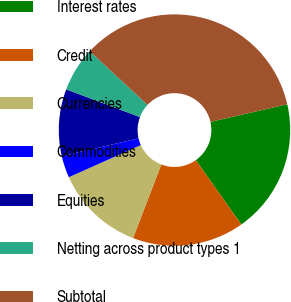<chart> <loc_0><loc_0><loc_500><loc_500><pie_chart><fcel>Interest rates<fcel>Credit<fcel>Currencies<fcel>Commodities<fcel>Equities<fcel>Netting across product types 1<fcel>Subtotal<nl><fcel>18.78%<fcel>15.63%<fcel>12.49%<fcel>3.06%<fcel>9.35%<fcel>6.2%<fcel>34.5%<nl></chart> 